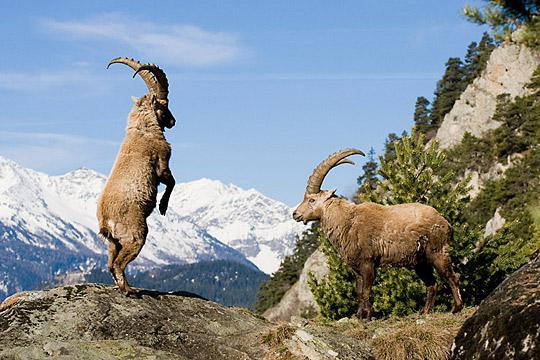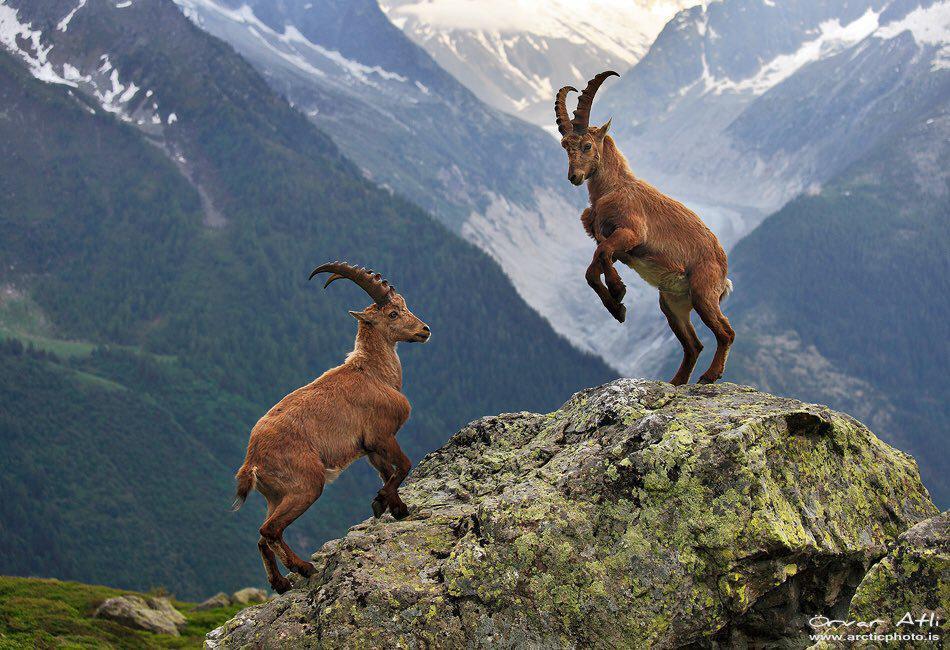The first image is the image on the left, the second image is the image on the right. Assess this claim about the two images: "There's no more than one mountain goat in the right image.". Correct or not? Answer yes or no. No. The first image is the image on the left, the second image is the image on the right. Evaluate the accuracy of this statement regarding the images: "One animal is standing on two feet in the image on the left.". Is it true? Answer yes or no. Yes. 